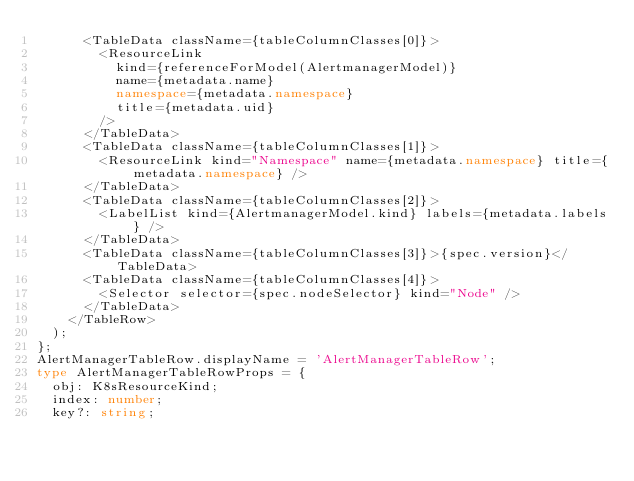<code> <loc_0><loc_0><loc_500><loc_500><_TypeScript_>      <TableData className={tableColumnClasses[0]}>
        <ResourceLink
          kind={referenceForModel(AlertmanagerModel)}
          name={metadata.name}
          namespace={metadata.namespace}
          title={metadata.uid}
        />
      </TableData>
      <TableData className={tableColumnClasses[1]}>
        <ResourceLink kind="Namespace" name={metadata.namespace} title={metadata.namespace} />
      </TableData>
      <TableData className={tableColumnClasses[2]}>
        <LabelList kind={AlertmanagerModel.kind} labels={metadata.labels} />
      </TableData>
      <TableData className={tableColumnClasses[3]}>{spec.version}</TableData>
      <TableData className={tableColumnClasses[4]}>
        <Selector selector={spec.nodeSelector} kind="Node" />
      </TableData>
    </TableRow>
  );
};
AlertManagerTableRow.displayName = 'AlertManagerTableRow';
type AlertManagerTableRowProps = {
  obj: K8sResourceKind;
  index: number;
  key?: string;</code> 